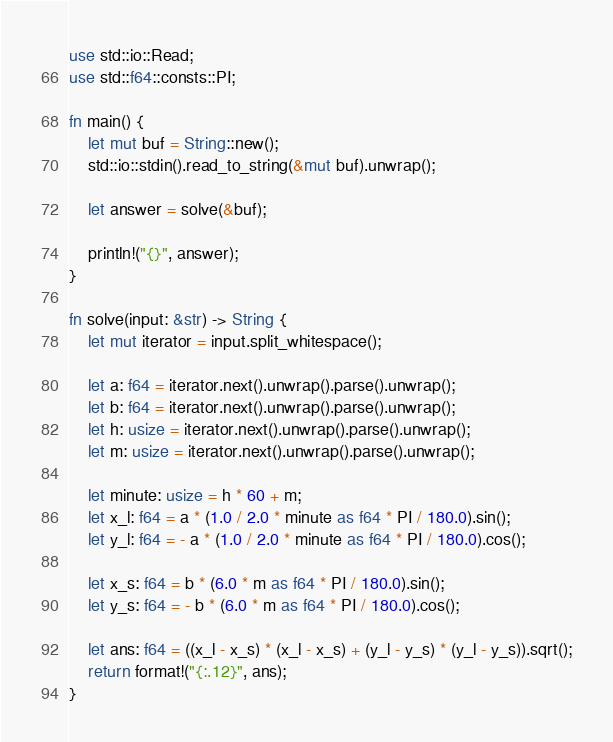Convert code to text. <code><loc_0><loc_0><loc_500><loc_500><_Rust_>use std::io::Read;
use std::f64::consts::PI;

fn main() {
    let mut buf = String::new();
    std::io::stdin().read_to_string(&mut buf).unwrap();

    let answer = solve(&buf);

    println!("{}", answer);
}

fn solve(input: &str) -> String {
    let mut iterator = input.split_whitespace();

    let a: f64 = iterator.next().unwrap().parse().unwrap();
    let b: f64 = iterator.next().unwrap().parse().unwrap();
    let h: usize = iterator.next().unwrap().parse().unwrap();
    let m: usize = iterator.next().unwrap().parse().unwrap();

    let minute: usize = h * 60 + m;
    let x_l: f64 = a * (1.0 / 2.0 * minute as f64 * PI / 180.0).sin();
    let y_l: f64 = - a * (1.0 / 2.0 * minute as f64 * PI / 180.0).cos();

    let x_s: f64 = b * (6.0 * m as f64 * PI / 180.0).sin();
    let y_s: f64 = - b * (6.0 * m as f64 * PI / 180.0).cos();

    let ans: f64 = ((x_l - x_s) * (x_l - x_s) + (y_l - y_s) * (y_l - y_s)).sqrt();
    return format!("{:.12}", ans);
}
</code> 